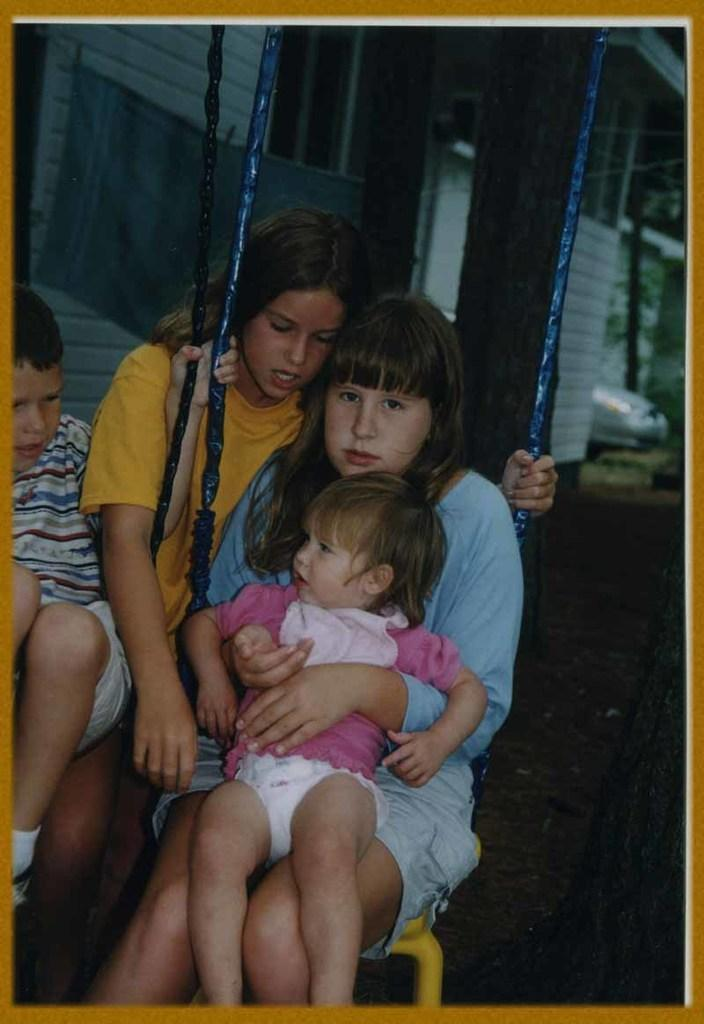How many children are in the image? There are two children in the image, a boy and a girl. What are the boy and girl doing in the image? They are holding a baby and sitting on a swinger. Is there anyone else in the image besides the children? Yes, there is another girl standing behind them. What can be seen in the background of the image? There is a building in the background of the image. What type of hair product is the boy using in the image? There is no hair product visible in the image, as the focus is on the children holding a baby and sitting on a swinger. 